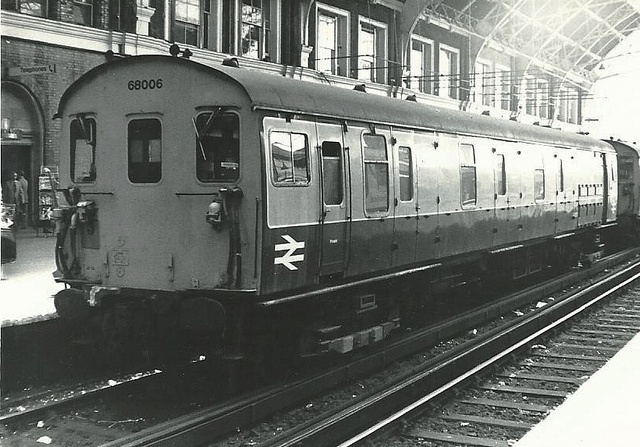Describe the objects in this image and their specific colors. I can see train in lightgray, gray, black, ivory, and darkgray tones, people in lightgray, gray, black, and darkgray tones, and people in lightgray, gray, and black tones in this image. 